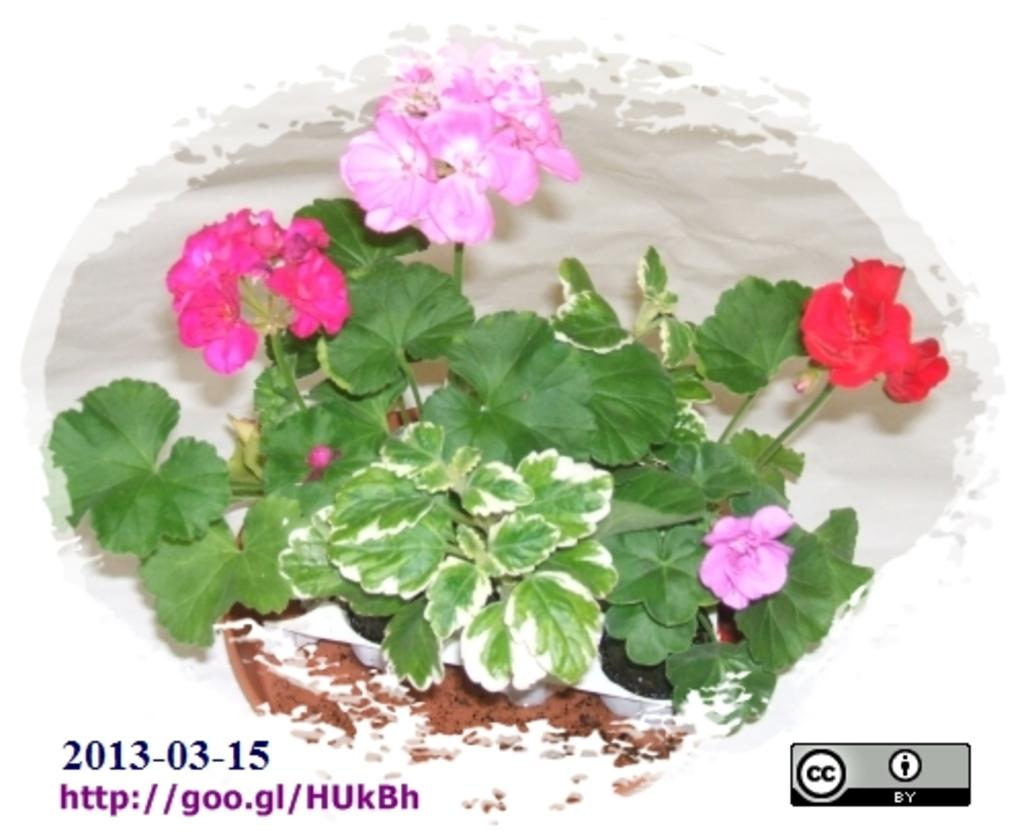What type of plant material can be seen in the image? There are leaves and flowers in the image. What else is present in the image besides plant material? There is text in the image. What color is the background of the image? The background of the image is white. Is there any blood visible on the skirt in the image? There is no skirt or blood present in the image. 